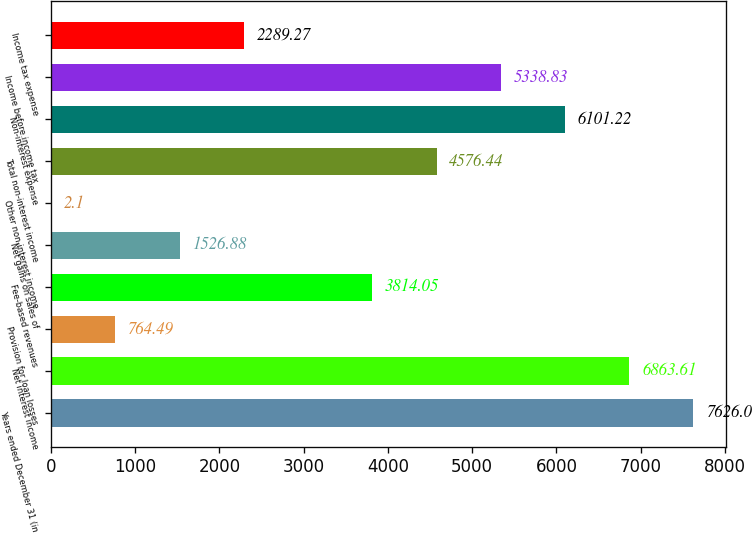Convert chart. <chart><loc_0><loc_0><loc_500><loc_500><bar_chart><fcel>Years ended December 31 (in<fcel>Net interest income<fcel>Provision for loan losses<fcel>Fee-based revenues<fcel>Net gains on sales of<fcel>Other non-interest income<fcel>Total non-interest income<fcel>Non-interest expense<fcel>Income before income tax<fcel>Income tax expense<nl><fcel>7626<fcel>6863.61<fcel>764.49<fcel>3814.05<fcel>1526.88<fcel>2.1<fcel>4576.44<fcel>6101.22<fcel>5338.83<fcel>2289.27<nl></chart> 